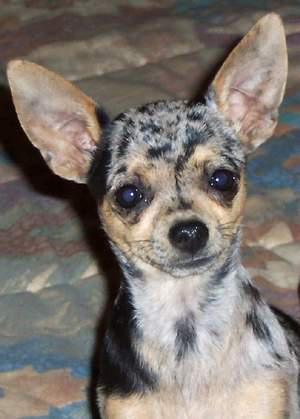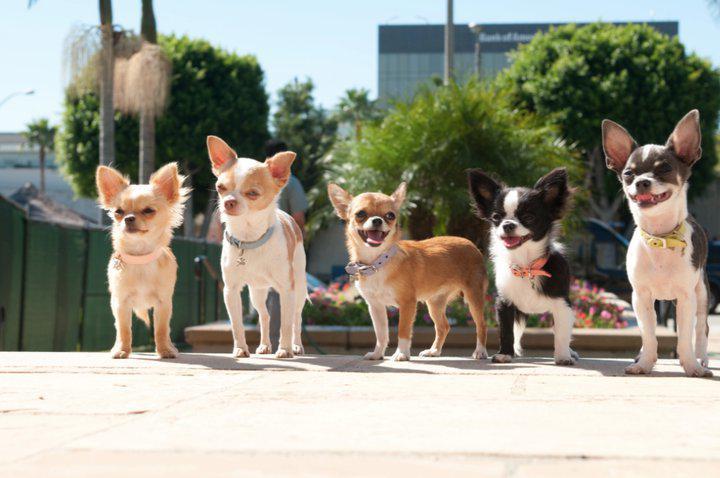The first image is the image on the left, the second image is the image on the right. Given the left and right images, does the statement "there are at least five animals in one of the images" hold true? Answer yes or no. Yes. The first image is the image on the left, the second image is the image on the right. Analyze the images presented: Is the assertion "There are 2 dogs with heads that are at least level." valid? Answer yes or no. No. The first image is the image on the left, the second image is the image on the right. For the images displayed, is the sentence "There are two dogs" factually correct? Answer yes or no. No. The first image is the image on the left, the second image is the image on the right. Considering the images on both sides, is "Exactly two little dogs are shown, one wearing a collar." valid? Answer yes or no. No. 